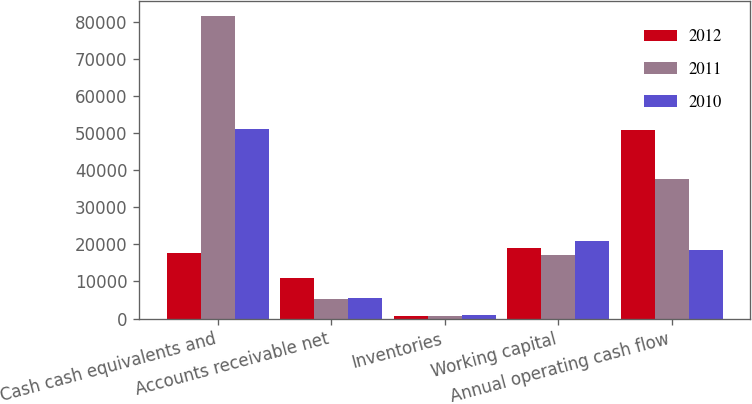Convert chart. <chart><loc_0><loc_0><loc_500><loc_500><stacked_bar_chart><ecel><fcel>Cash cash equivalents and<fcel>Accounts receivable net<fcel>Inventories<fcel>Working capital<fcel>Annual operating cash flow<nl><fcel>2012<fcel>17806.5<fcel>10930<fcel>791<fcel>19111<fcel>50856<nl><fcel>2011<fcel>81570<fcel>5369<fcel>776<fcel>17018<fcel>37529<nl><fcel>2010<fcel>51011<fcel>5510<fcel>1051<fcel>20956<fcel>18595<nl></chart> 